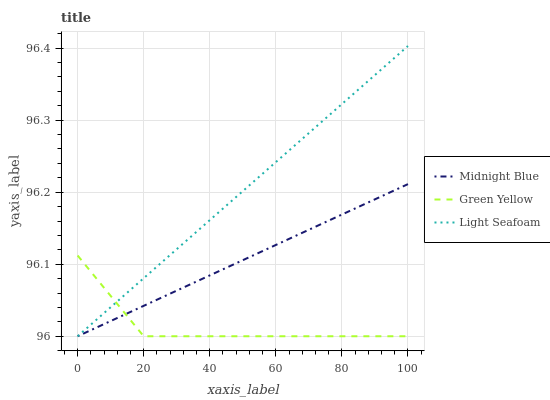Does Green Yellow have the minimum area under the curve?
Answer yes or no. Yes. Does Light Seafoam have the maximum area under the curve?
Answer yes or no. Yes. Does Midnight Blue have the minimum area under the curve?
Answer yes or no. No. Does Midnight Blue have the maximum area under the curve?
Answer yes or no. No. Is Light Seafoam the smoothest?
Answer yes or no. Yes. Is Green Yellow the roughest?
Answer yes or no. Yes. Is Midnight Blue the smoothest?
Answer yes or no. No. Is Midnight Blue the roughest?
Answer yes or no. No. Does Green Yellow have the lowest value?
Answer yes or no. Yes. Does Light Seafoam have the highest value?
Answer yes or no. Yes. Does Midnight Blue have the highest value?
Answer yes or no. No. Does Light Seafoam intersect Midnight Blue?
Answer yes or no. Yes. Is Light Seafoam less than Midnight Blue?
Answer yes or no. No. Is Light Seafoam greater than Midnight Blue?
Answer yes or no. No. 